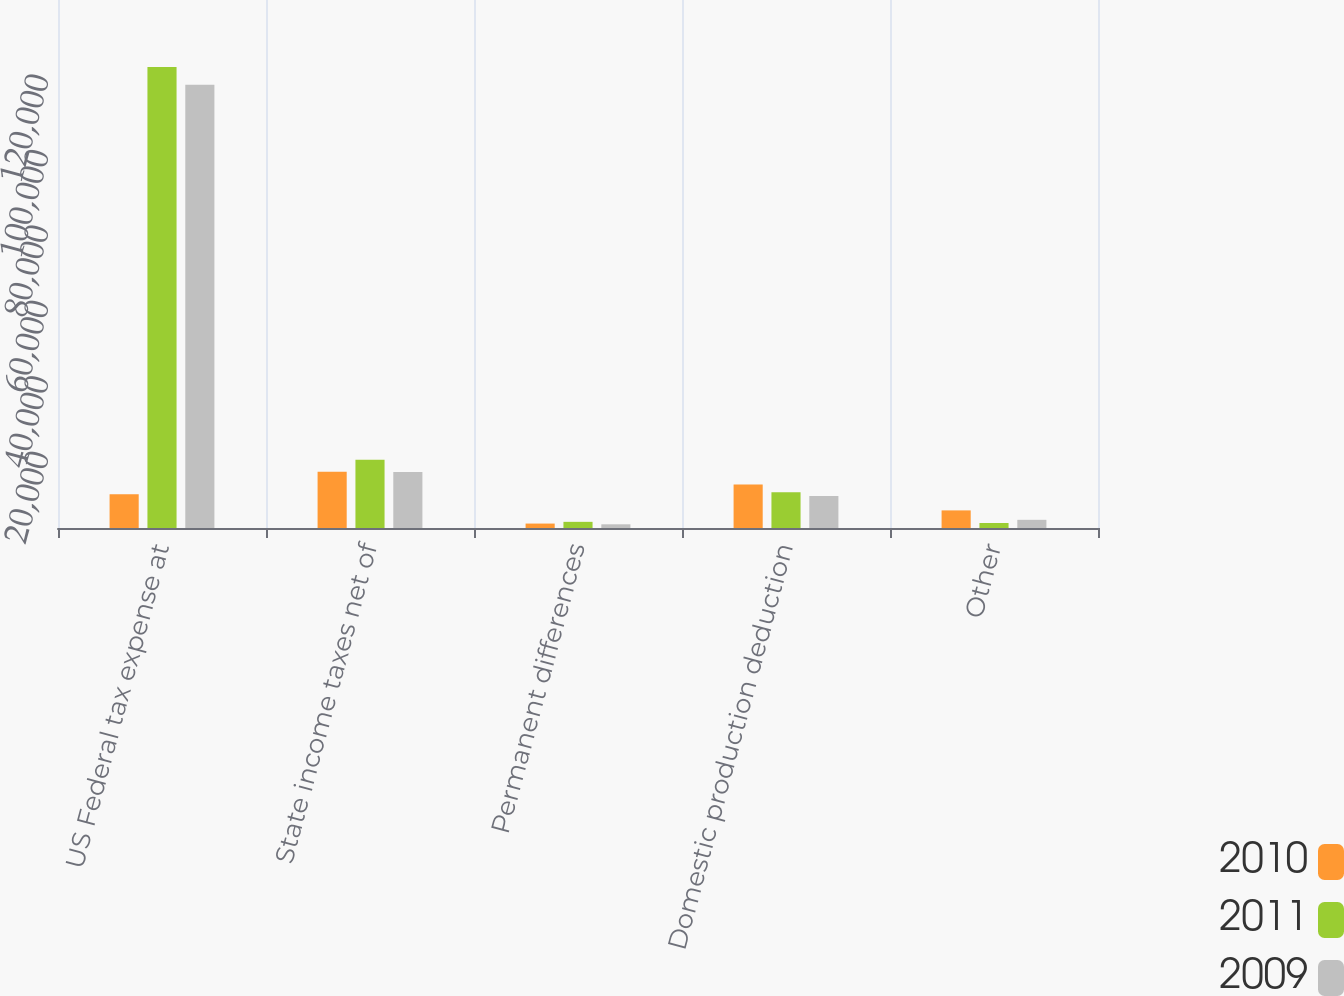Convert chart. <chart><loc_0><loc_0><loc_500><loc_500><stacked_bar_chart><ecel><fcel>US Federal tax expense at<fcel>State income taxes net of<fcel>Permanent differences<fcel>Domestic production deduction<fcel>Other<nl><fcel>2010<fcel>8972.5<fcel>14917<fcel>1176<fcel>11551<fcel>4667<nl><fcel>2011<fcel>122256<fcel>18126<fcel>1634<fcel>9450<fcel>1330<nl><fcel>2009<fcel>117510<fcel>14819<fcel>977<fcel>8495<fcel>2168<nl></chart> 